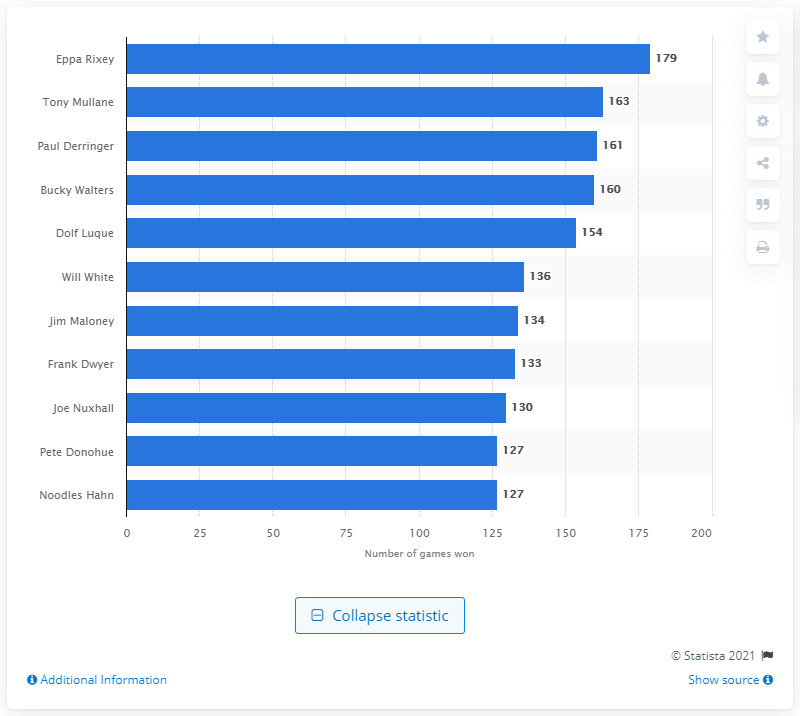Highlight a few significant elements in this photo. Eppa Rixey, a player for the Cincinnati Reds franchise, has won the most games in the team's history. 